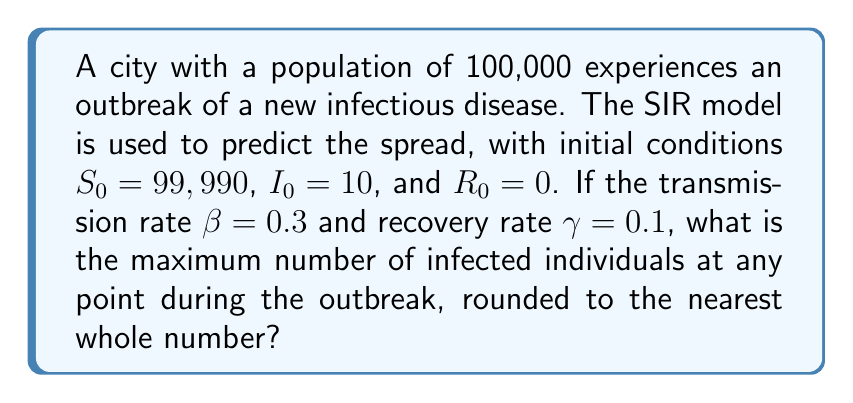Show me your answer to this math problem. To solve this problem, we'll use the SIR model equations and find the peak of the infected population:

1. The SIR model equations are:
   $$\frac{dS}{dt} = -\beta SI$$
   $$\frac{dI}{dt} = \beta SI - \gamma I$$
   $$\frac{dR}{dt} = \gamma I$$

2. The peak of infection occurs when $\frac{dI}{dt} = 0$, which means:
   $$\beta SI - \gamma I = 0$$

3. Solving for S at this point:
   $$S = \frac{\gamma}{\beta} = \frac{0.1}{0.3} = \frac{1}{3}$$

4. The total population N is constant:
   $$N = S + I + R = 100,000$$

5. At the peak, we can write:
   $$\frac{1}{3}N + I + R = N$$

6. Solving for I:
   $$I = N - \frac{1}{3}N - R = \frac{2}{3}N - R$$

7. The maximum I occurs when R is minimum. Since R starts at 0 and only increases, the minimum R is 0.

8. Therefore, the maximum I is:
   $$I_{max} = \frac{2}{3}N = \frac{2}{3} \cdot 100,000 = 66,666.67$$

9. Rounding to the nearest whole number:
   $$I_{max} \approx 66,667$$
Answer: 66,667 